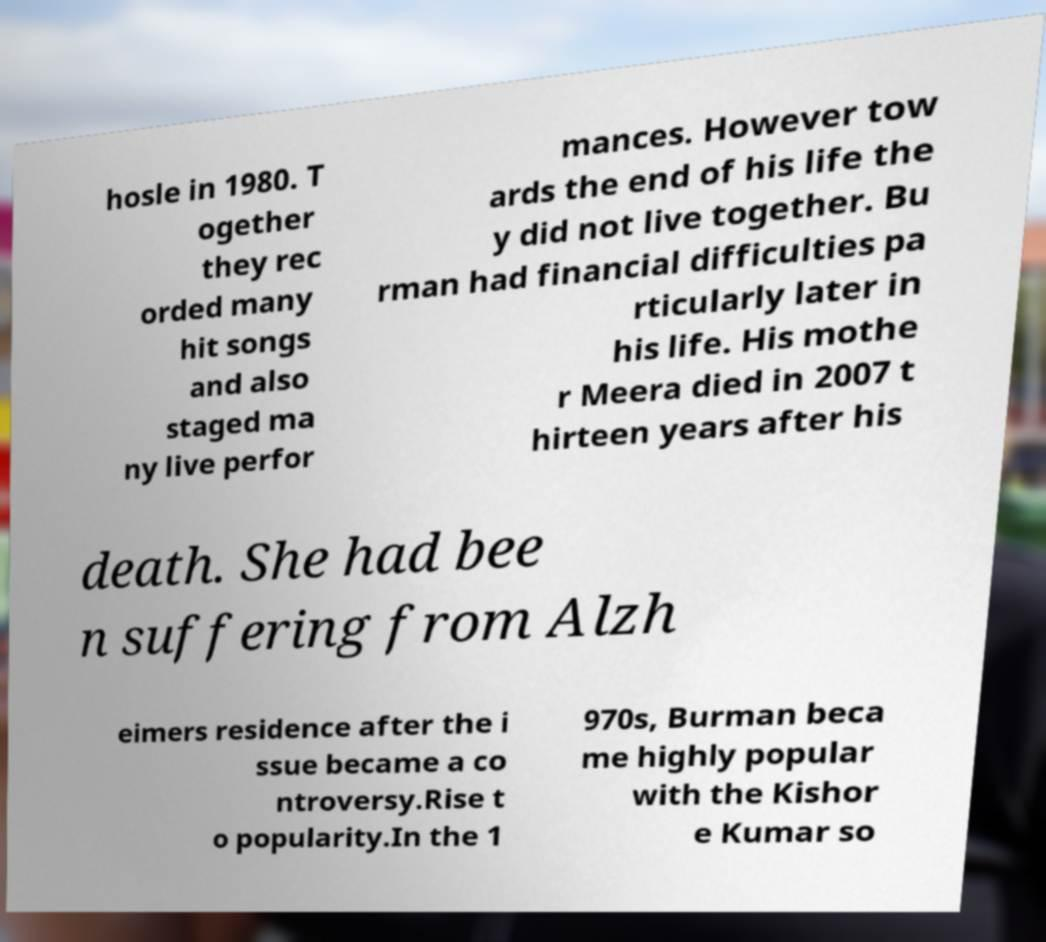Could you assist in decoding the text presented in this image and type it out clearly? hosle in 1980. T ogether they rec orded many hit songs and also staged ma ny live perfor mances. However tow ards the end of his life the y did not live together. Bu rman had financial difficulties pa rticularly later in his life. His mothe r Meera died in 2007 t hirteen years after his death. She had bee n suffering from Alzh eimers residence after the i ssue became a co ntroversy.Rise t o popularity.In the 1 970s, Burman beca me highly popular with the Kishor e Kumar so 